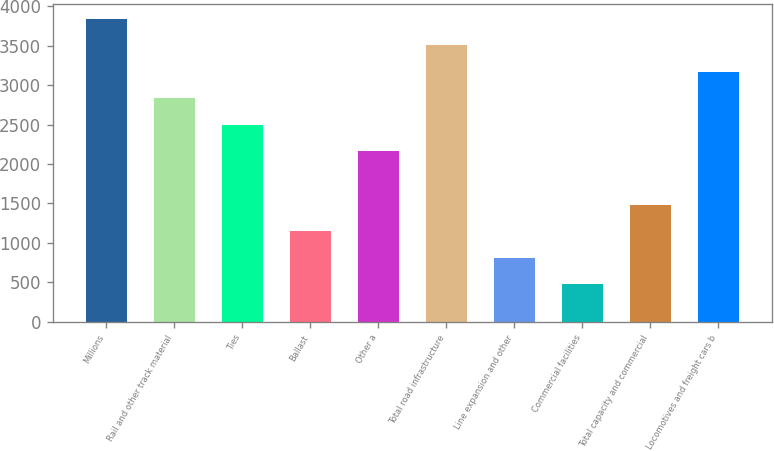Convert chart. <chart><loc_0><loc_0><loc_500><loc_500><bar_chart><fcel>Millions<fcel>Rail and other track material<fcel>Ties<fcel>Ballast<fcel>Other a<fcel>Total road infrastructure<fcel>Line expansion and other<fcel>Commercial facilities<fcel>Total capacity and commercial<fcel>Locomotives and freight cars b<nl><fcel>3841.7<fcel>2831.6<fcel>2494.9<fcel>1148.1<fcel>2158.2<fcel>3505<fcel>811.4<fcel>474.7<fcel>1484.8<fcel>3168.3<nl></chart> 